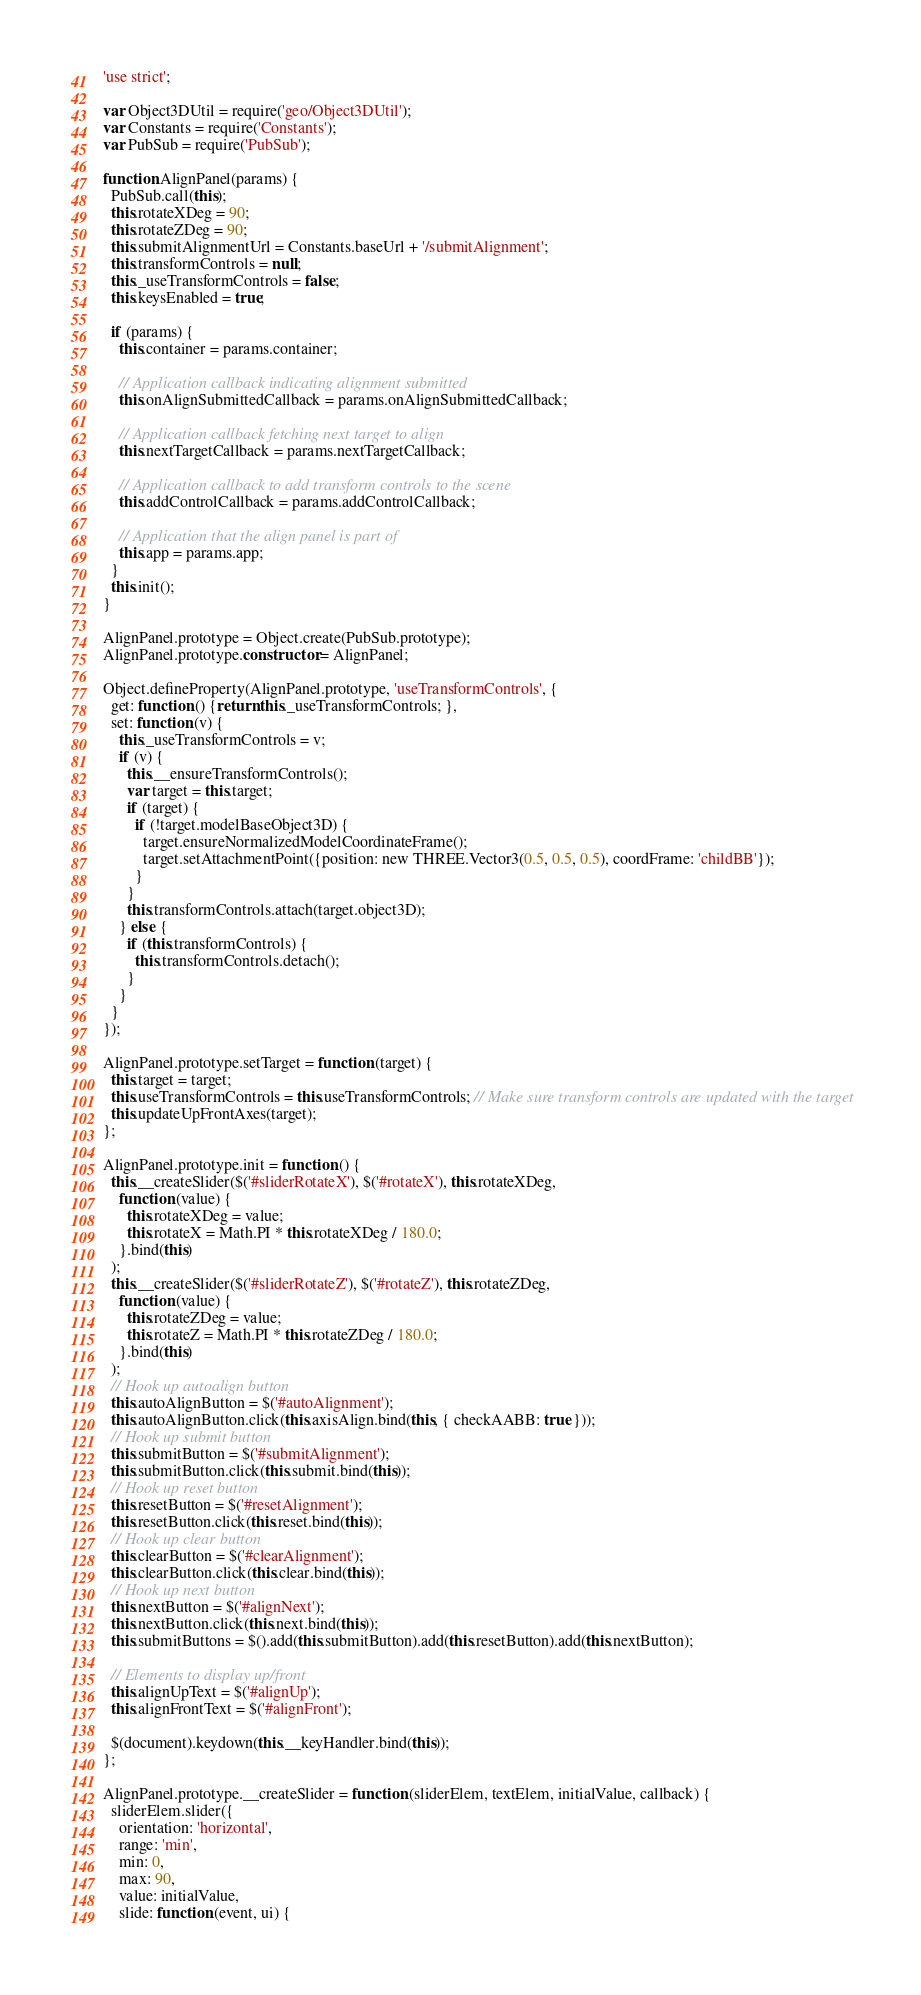<code> <loc_0><loc_0><loc_500><loc_500><_JavaScript_>'use strict';

var Object3DUtil = require('geo/Object3DUtil');
var Constants = require('Constants');
var PubSub = require('PubSub');

function AlignPanel(params) {
  PubSub.call(this);
  this.rotateXDeg = 90;
  this.rotateZDeg = 90;
  this.submitAlignmentUrl = Constants.baseUrl + '/submitAlignment';
  this.transformControls = null;
  this._useTransformControls = false;
  this.keysEnabled = true;

  if (params) {
    this.container = params.container;

    // Application callback indicating alignment submitted
    this.onAlignSubmittedCallback = params.onAlignSubmittedCallback;

    // Application callback fetching next target to align
    this.nextTargetCallback = params.nextTargetCallback;

    // Application callback to add transform controls to the scene
    this.addControlCallback = params.addControlCallback;

    // Application that the align panel is part of
    this.app = params.app;
  }
  this.init();
}

AlignPanel.prototype = Object.create(PubSub.prototype);
AlignPanel.prototype.constructor = AlignPanel;

Object.defineProperty(AlignPanel.prototype, 'useTransformControls', {
  get: function () {return this._useTransformControls; },
  set: function (v) {
    this._useTransformControls = v;
    if (v) {
      this.__ensureTransformControls();
      var target = this.target;
      if (target) {
        if (!target.modelBaseObject3D) {
          target.ensureNormalizedModelCoordinateFrame();
          target.setAttachmentPoint({position: new THREE.Vector3(0.5, 0.5, 0.5), coordFrame: 'childBB'});
        }
      }
      this.transformControls.attach(target.object3D);
    } else {
      if (this.transformControls) {
        this.transformControls.detach();
      }
    }
  }
});

AlignPanel.prototype.setTarget = function (target) {
  this.target = target;
  this.useTransformControls = this.useTransformControls; // Make sure transform controls are updated with the target
  this.updateUpFrontAxes(target);
};

AlignPanel.prototype.init = function () {
  this.__createSlider($('#sliderRotateX'), $('#rotateX'), this.rotateXDeg,
    function (value) {
      this.rotateXDeg = value;
      this.rotateX = Math.PI * this.rotateXDeg / 180.0;
    }.bind(this)
  );
  this.__createSlider($('#sliderRotateZ'), $('#rotateZ'), this.rotateZDeg,
    function (value) {
      this.rotateZDeg = value;
      this.rotateZ = Math.PI * this.rotateZDeg / 180.0;
    }.bind(this)
  );
  // Hook up autoalign button
  this.autoAlignButton = $('#autoAlignment');
  this.autoAlignButton.click(this.axisAlign.bind(this, { checkAABB: true }));
  // Hook up submit button
  this.submitButton = $('#submitAlignment');
  this.submitButton.click(this.submit.bind(this));
  // Hook up reset button
  this.resetButton = $('#resetAlignment');
  this.resetButton.click(this.reset.bind(this));
  // Hook up clear button
  this.clearButton = $('#clearAlignment');
  this.clearButton.click(this.clear.bind(this));
  // Hook up next button
  this.nextButton = $('#alignNext');
  this.nextButton.click(this.next.bind(this));
  this.submitButtons = $().add(this.submitButton).add(this.resetButton).add(this.nextButton);

  // Elements to display up/front
  this.alignUpText = $('#alignUp');
  this.alignFrontText = $('#alignFront');

  $(document).keydown(this.__keyHandler.bind(this));
};

AlignPanel.prototype.__createSlider = function (sliderElem, textElem, initialValue, callback) {
  sliderElem.slider({
    orientation: 'horizontal',
    range: 'min',
    min: 0,
    max: 90,
    value: initialValue,
    slide: function (event, ui) {</code> 